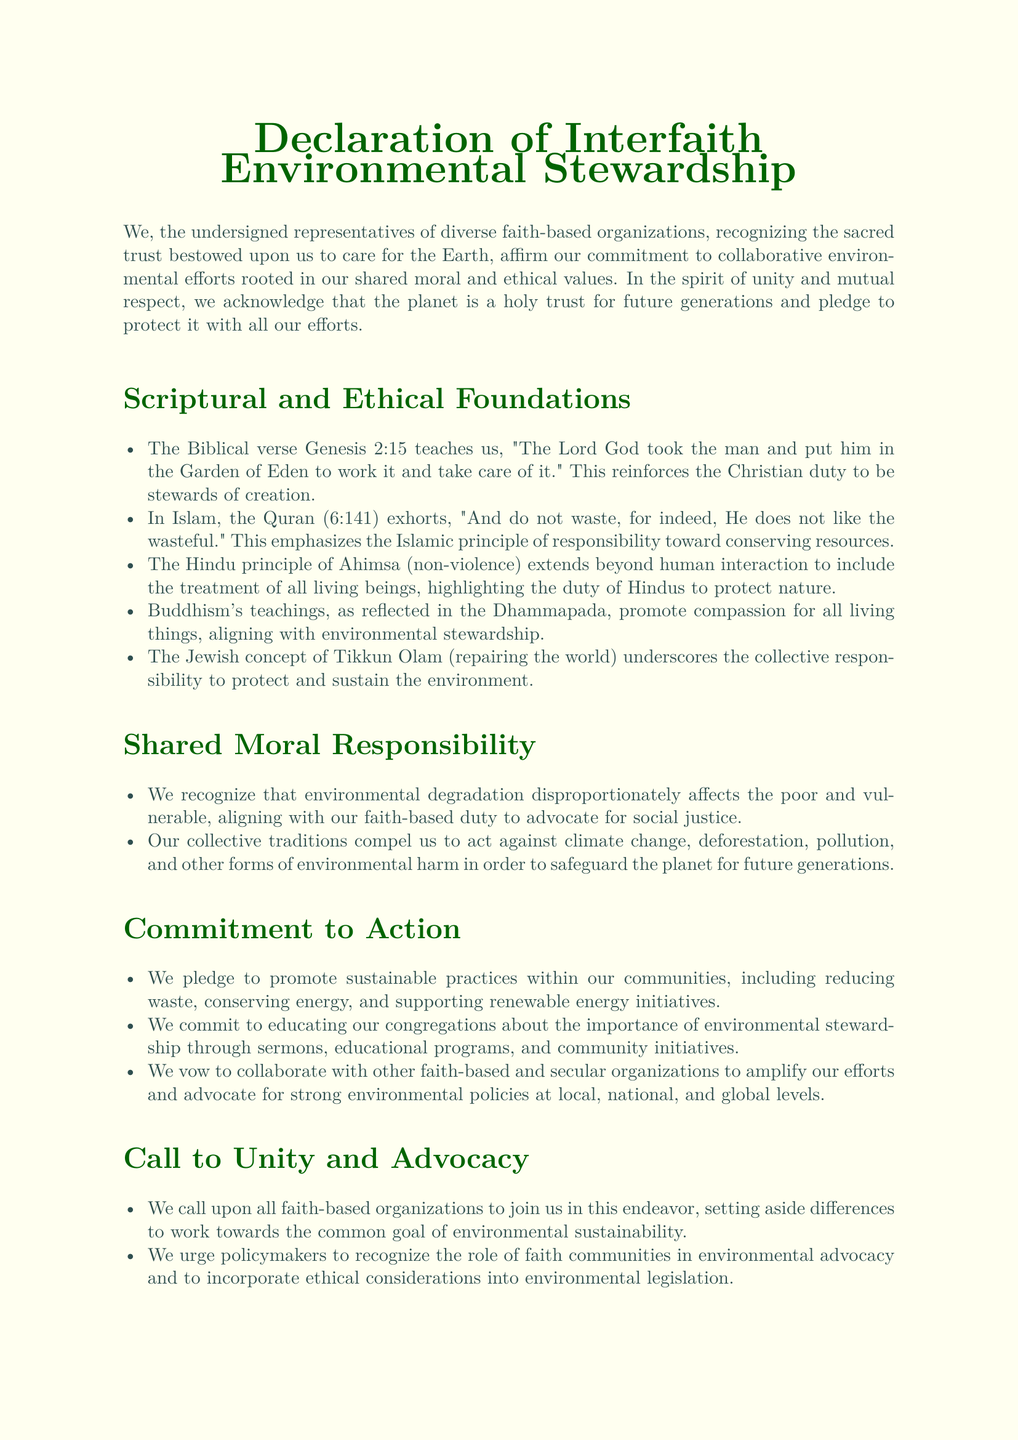What is the title of the document? The title is the formal name given to the declaration, which is indicated at the beginning of the document.
Answer: Declaration of Interfaith Environmental Stewardship Who signed the declaration? The signatories are representatives from various faith-based organizations, as mentioned towards the end of the document.
Answer: Representatives of Faith-Based Organizations Worldwide Which Biblical verse is mentioned as a foundation for stewardship? This verse is used to illustrate the Christian perspective on caring for creation and is specifically quoted in the document.
Answer: Genesis 2:15 What Islamic principle emphasizes resource conservation? This principle is highlighted as a teaching in the Islamic tradition regarding the use of resources.
Answer: Do not waste What Hindu principle relates to environmental stewardship? This principle underscores the duty to protect nature and is a significant aspect of Hindu teachings.
Answer: Ahimsa What does Tikkun Olam mean? This concept from Jewish tradition is referenced as part of the collective responsibility toward environmental protection.
Answer: repairing the world What commitments are made regarding community education? This commitment focuses on informing community members about environmental stewardship through various means.
Answer: educating our congregations Which urgent issue do the faith-based organizations agree to act against? This issue represents a major environmental concern that affects the planet and future generations, as mentioned in the document.
Answer: climate change 